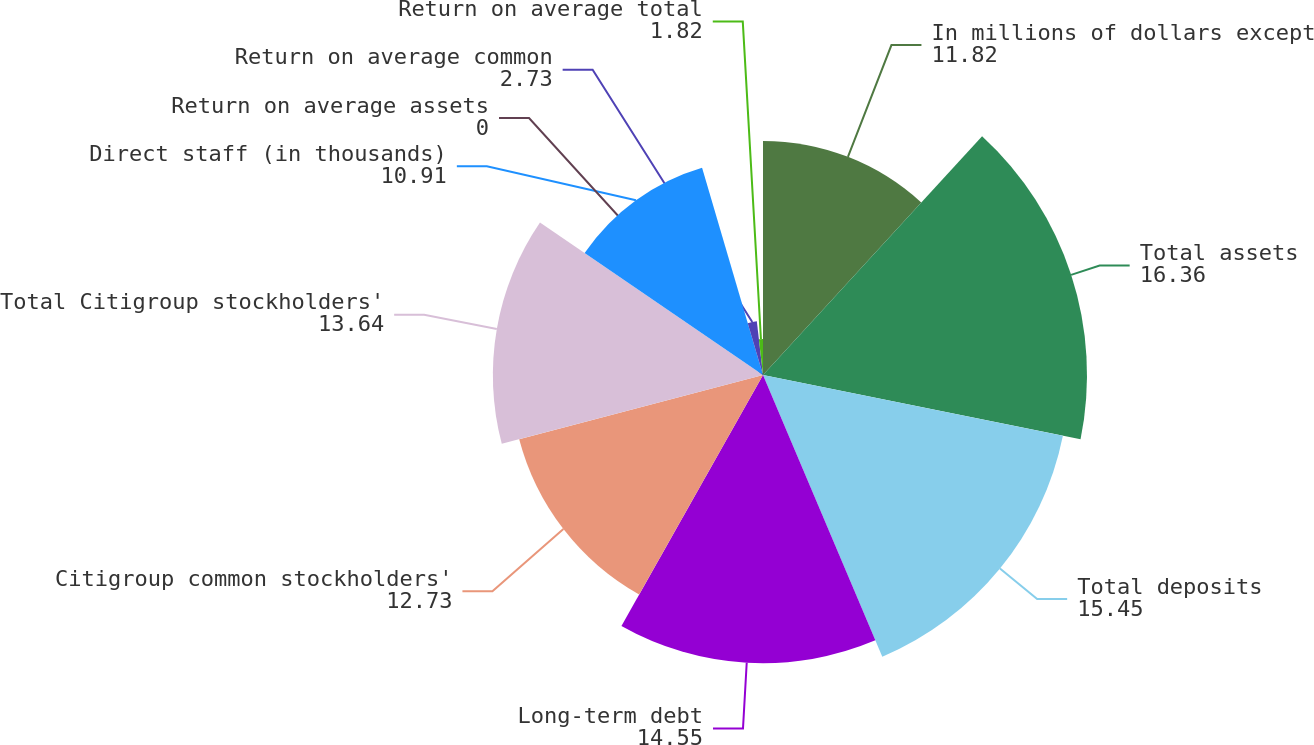Convert chart to OTSL. <chart><loc_0><loc_0><loc_500><loc_500><pie_chart><fcel>In millions of dollars except<fcel>Total assets<fcel>Total deposits<fcel>Long-term debt<fcel>Citigroup common stockholders'<fcel>Total Citigroup stockholders'<fcel>Direct staff (in thousands)<fcel>Return on average assets<fcel>Return on average common<fcel>Return on average total<nl><fcel>11.82%<fcel>16.36%<fcel>15.45%<fcel>14.55%<fcel>12.73%<fcel>13.64%<fcel>10.91%<fcel>0.0%<fcel>2.73%<fcel>1.82%<nl></chart> 